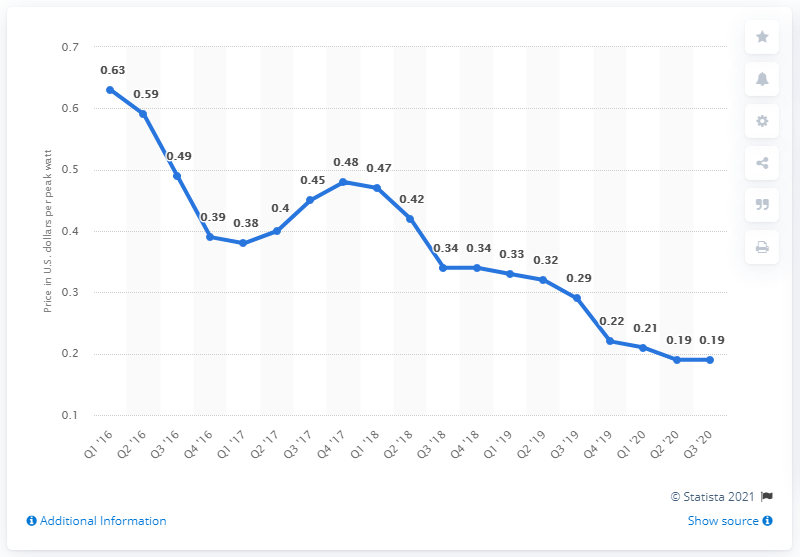Give some essential details in this illustration. The average price per watt of solar photovoltaic modules in the United States during the first quarter of 2016 was 0.63 dollars. In the third quarter of 2020, the average price per watt of solar photovoltaic modules in the United States was 0.19. 